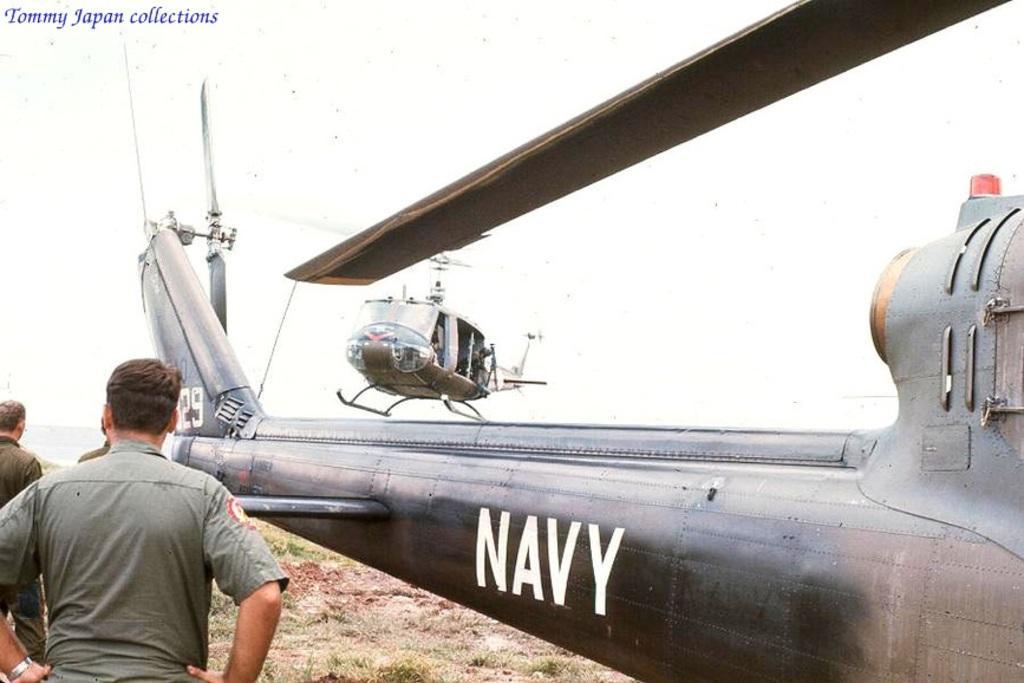In one or two sentences, can you explain what this image depicts? In the left bottom of the picture, we see three men in uniform are standing. Beside them, we see a helicopter on which "NAVY" is written. Beside that, we see another helicopter. In the background, it is white in color. At the bottom of the picture, we see grass. 